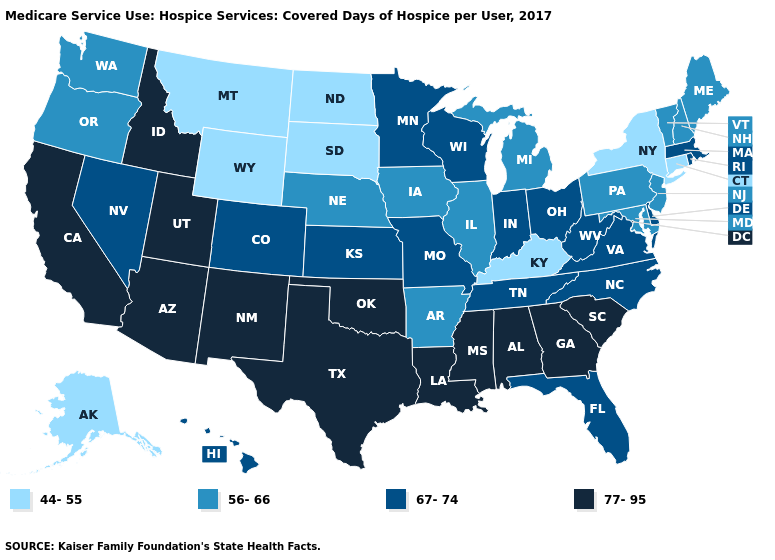Does Wisconsin have the highest value in the MidWest?
Be succinct. Yes. Name the states that have a value in the range 56-66?
Quick response, please. Arkansas, Illinois, Iowa, Maine, Maryland, Michigan, Nebraska, New Hampshire, New Jersey, Oregon, Pennsylvania, Vermont, Washington. Among the states that border Utah , which have the lowest value?
Give a very brief answer. Wyoming. What is the value of Kentucky?
Short answer required. 44-55. Does Kentucky have the lowest value in the South?
Quick response, please. Yes. Name the states that have a value in the range 77-95?
Write a very short answer. Alabama, Arizona, California, Georgia, Idaho, Louisiana, Mississippi, New Mexico, Oklahoma, South Carolina, Texas, Utah. What is the value of Arkansas?
Concise answer only. 56-66. Among the states that border Montana , which have the highest value?
Quick response, please. Idaho. Among the states that border Iowa , which have the lowest value?
Answer briefly. South Dakota. Among the states that border Texas , does Louisiana have the lowest value?
Quick response, please. No. What is the value of Virginia?
Be succinct. 67-74. What is the value of Massachusetts?
Quick response, please. 67-74. Does Wisconsin have the highest value in the MidWest?
Give a very brief answer. Yes. What is the value of Alabama?
Quick response, please. 77-95. Does Delaware have the lowest value in the South?
Quick response, please. No. 